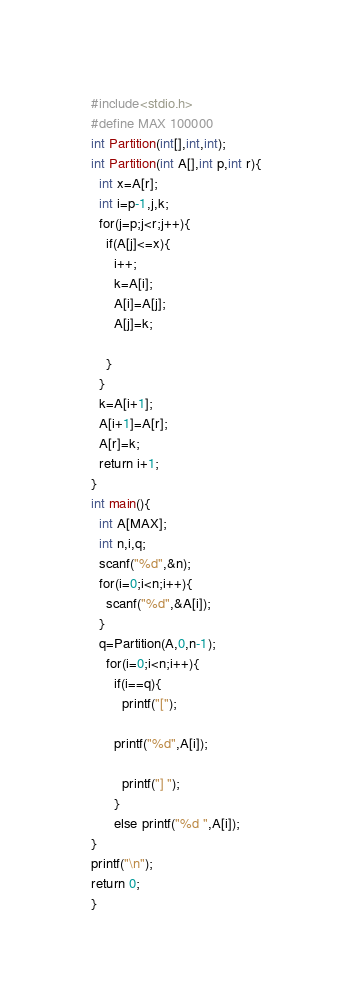Convert code to text. <code><loc_0><loc_0><loc_500><loc_500><_C_>#include<stdio.h>
#define MAX 100000
int Partition(int[],int,int);
int Partition(int A[],int p,int r){
  int x=A[r];
  int i=p-1,j,k;
  for(j=p;j<r;j++){
    if(A[j]<=x){
      i++;
      k=A[i];
      A[i]=A[j];
      A[j]=k;

    }
  }
  k=A[i+1];
  A[i+1]=A[r];
  A[r]=k;
  return i+1;
}
int main(){
  int A[MAX];
  int n,i,q;
  scanf("%d",&n);
  for(i=0;i<n;i++){
    scanf("%d",&A[i]);
  }
  q=Partition(A,0,n-1);
    for(i=0;i<n;i++){
      if(i==q){
        printf("[");

      printf("%d",A[i]);

        printf("] ");
      }
      else printf("%d ",A[i]);
}
printf("\n");
return 0;
}</code> 